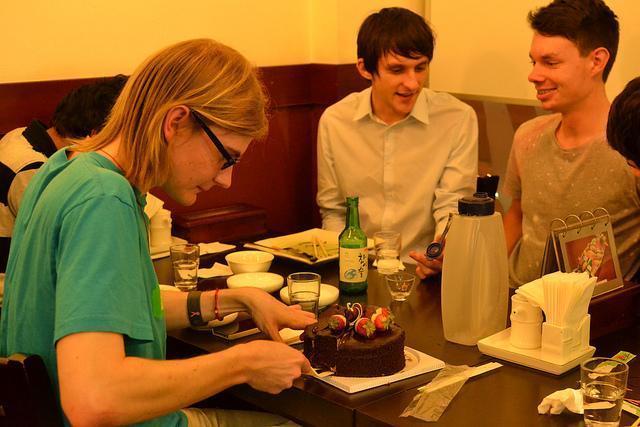How many people can you see?
Give a very brief answer. 5. How many cakes are there?
Give a very brief answer. 1. How many bottles are there?
Give a very brief answer. 2. 